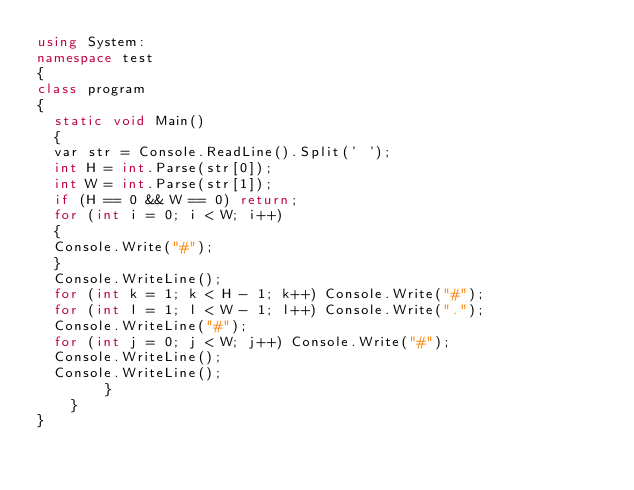<code> <loc_0><loc_0><loc_500><loc_500><_C#_>using System:
namespace test
{
class program
{
  static void Main()
  {
  var str = Console.ReadLine().Split(' ');
  int H = int.Parse(str[0]);
  int W = int.Parse(str[1]);
  if (H == 0 && W == 0) return;
  for (int i = 0; i < W; i++)
  {
  Console.Write("#");
  }
  Console.WriteLine();
  for (int k = 1; k < H - 1; k++) Console.Write("#");
  for (int l = 1; l < W - 1; l++) Console.Write(".");
  Console.WriteLine("#");
  for (int j = 0; j < W; j++) Console.Write("#");
  Console.WriteLine();
  Console.WriteLine();
        }
    }
}</code> 